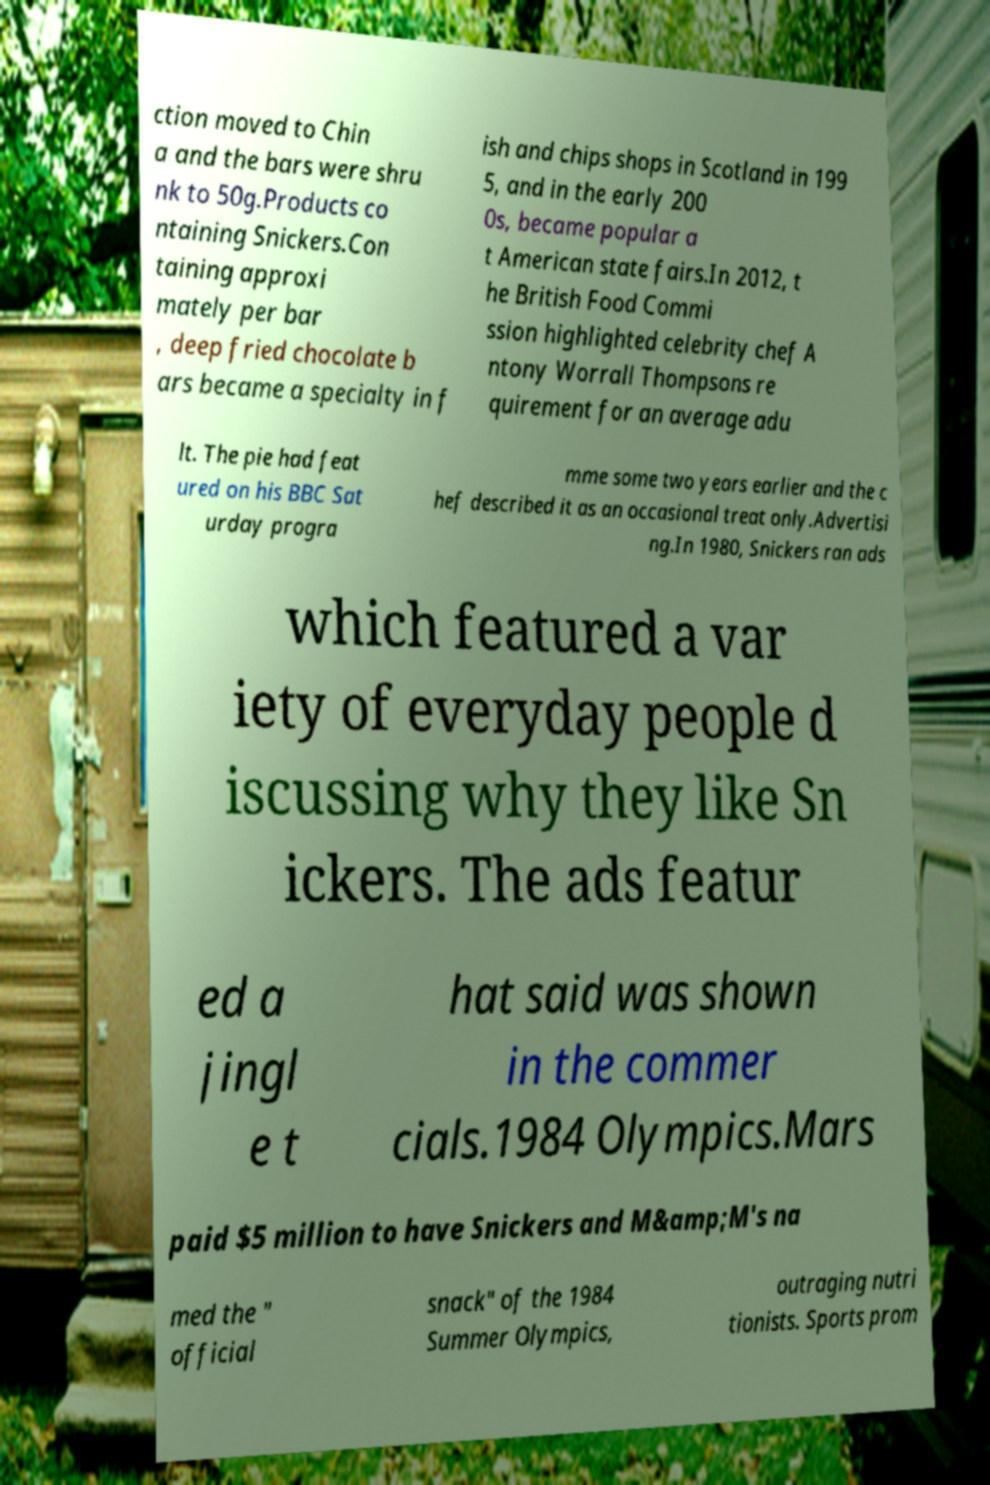Please read and relay the text visible in this image. What does it say? ction moved to Chin a and the bars were shru nk to 50g.Products co ntaining Snickers.Con taining approxi mately per bar , deep fried chocolate b ars became a specialty in f ish and chips shops in Scotland in 199 5, and in the early 200 0s, became popular a t American state fairs.In 2012, t he British Food Commi ssion highlighted celebrity chef A ntony Worrall Thompsons re quirement for an average adu lt. The pie had feat ured on his BBC Sat urday progra mme some two years earlier and the c hef described it as an occasional treat only.Advertisi ng.In 1980, Snickers ran ads which featured a var iety of everyday people d iscussing why they like Sn ickers. The ads featur ed a jingl e t hat said was shown in the commer cials.1984 Olympics.Mars paid $5 million to have Snickers and M&amp;M's na med the " official snack" of the 1984 Summer Olympics, outraging nutri tionists. Sports prom 